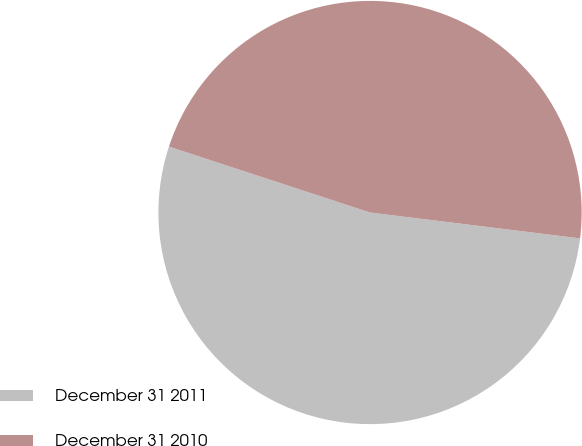Convert chart. <chart><loc_0><loc_0><loc_500><loc_500><pie_chart><fcel>December 31 2011<fcel>December 31 2010<nl><fcel>53.09%<fcel>46.91%<nl></chart> 